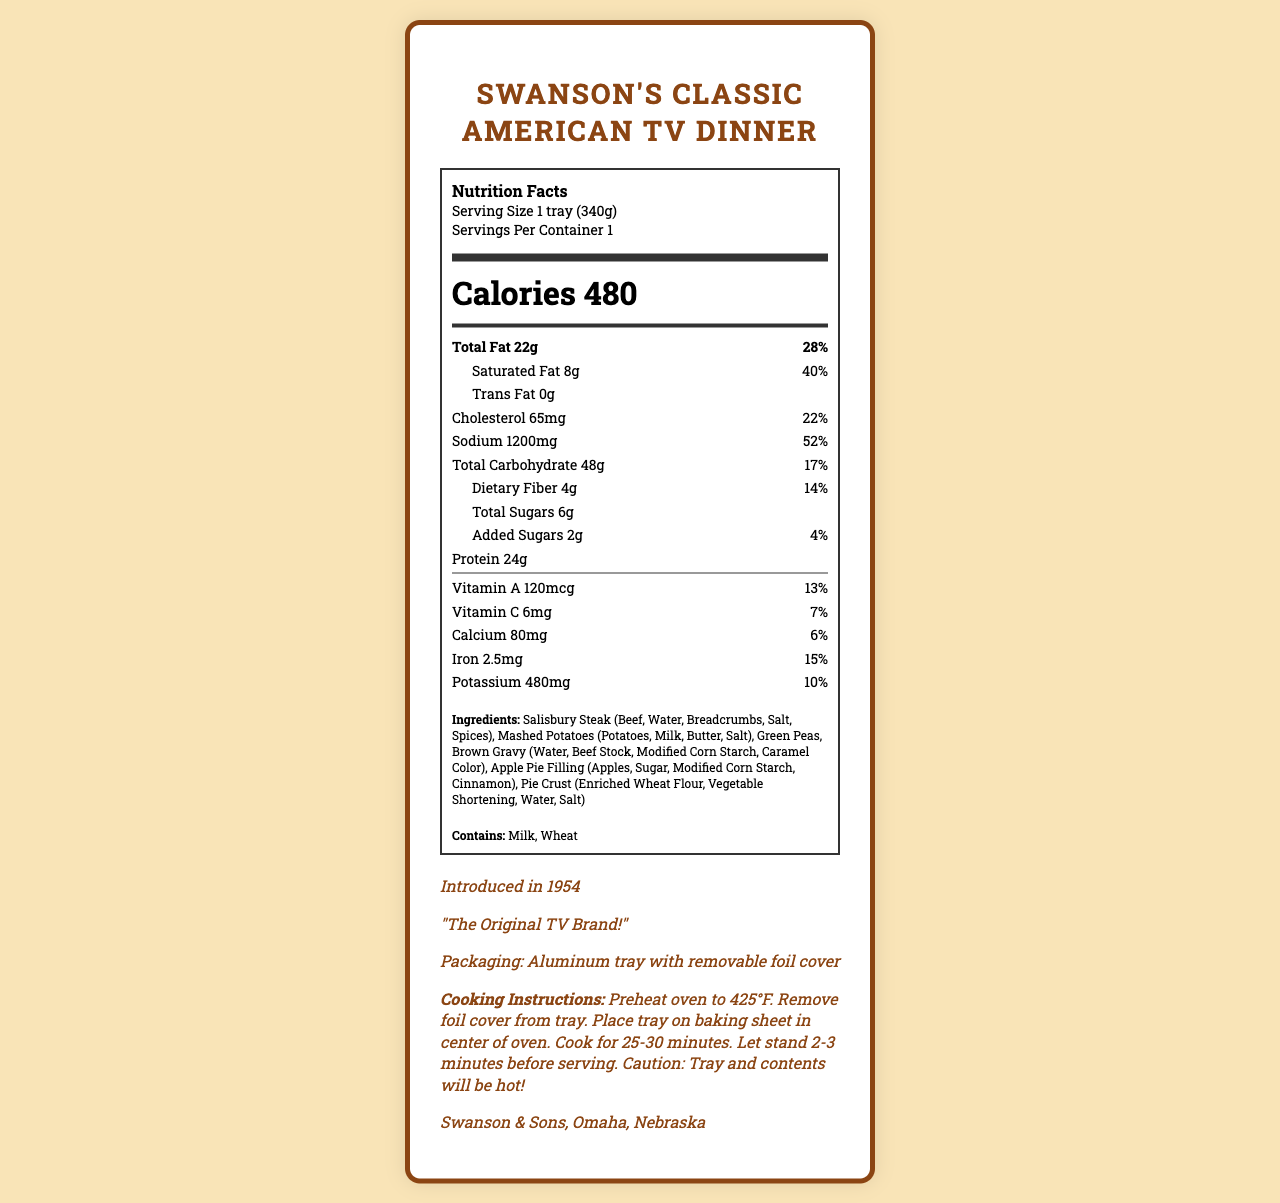what is the serving size of Swanson's Classic American TV Dinner? The serving size is listed as "1 tray (340g)" in the nutrition label.
Answer: 1 tray (340g) how many servings are there per container? The document lists "Servings Per Container: 1".
Answer: 1 how many calories are in one serving? The nutrition label specifies that there are 480 calories per serving.
Answer: 480 what is the amount of total fat in this TV dinner? The document indicates "Total Fat: 22g".
Answer: 22g what is the daily value percentage of saturated fat? The document shows "Saturated Fat: 8g (40%)".
Answer: 40% what is the amount of sodium in one tray? Sodium is listed as 1200mg in the nutrition facts.
Answer: 1200mg how much protein does this TV dinner contain? The document states that the TV dinner contains 24g of protein.
Answer: 24g what ingredients are included in the Salisbury Steak? The ingredients for Salisbury Steak are listed in the document as "Beef, Water, Breadcrumbs, Salt, Spices".
Answer: Beef, Water, Breadcrumbs, Salt, Spices which allergens are present in this product? The allergens section lists "Milk" and "Wheat".
Answer: Milk, Wheat which of the following nutrients has the highest daily value percentage? A. Vitamin A B. Iron C. Sodium Sodium has a daily value percentage of 52%, which surpasses Vitamin A's 13% and Iron's 15%.
Answer: C. Sodium how much added sugar does the TV dinner contain? A. 0g B. 1g C. 2g D. 3g The nutrition facts indicate that there are 2g of added sugars.
Answer: C. 2g is this product suitable for someone with a wheat allergy? The document lists "Wheat" as one of the allergens present in the product.
Answer: No summarize the main nutritional information and vintage details of this TV dinner. This document provides detailed nutritional facts about the TV dinner, its ingredients, allergens, and a brief historical background, including the vintage packaging and the ad slogan. The nutrition label helps understand its calorie count and composition while the historical information adds a nostalgic aspect.
Answer: This TV dinner, introduced in 1954 by Swanson, contains 480 calories and is packaged in an aluminum tray. Key nutritional information includes 22g of total fat, 1200mg of sodium, 48g of total carbohydrates, and 24g of protein. It includes allergens like milk and wheat. The vintage ad slogan is "The Original TV Brand!" and it has a cooking instruction detail. what year was Swanson's Classic American TV Dinner introduced? The document mentions that the product was introduced in 1954.
Answer: 1954 what is the source of vitamin C in this TV dinner? The document provides the amount of vitamin C but does not specify its source.
Answer: Cannot be determined how long should you preheat the oven before cooking this TV dinner? The cooking instructions state to preheat the oven to 425°F before cooking.
Answer: 425°F 